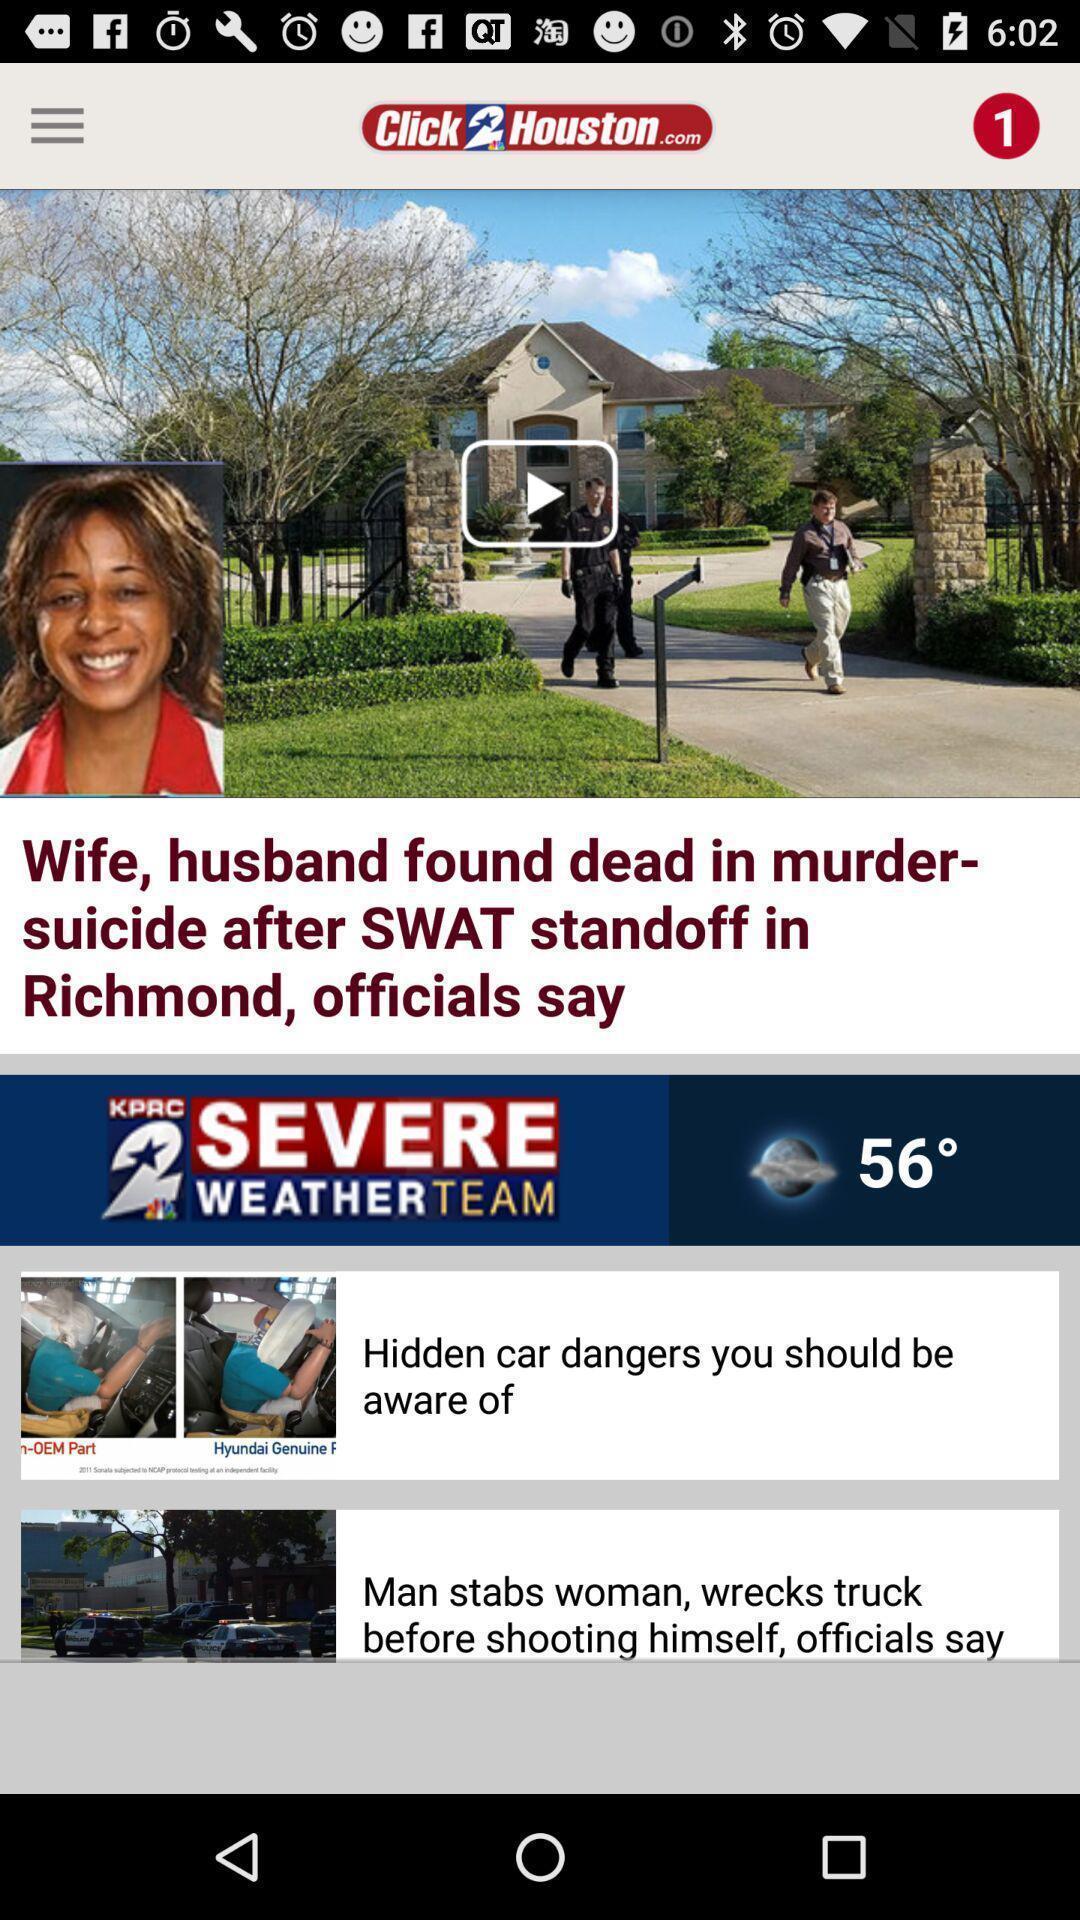Please provide a description for this image. Screen displaying multiple news articles. 